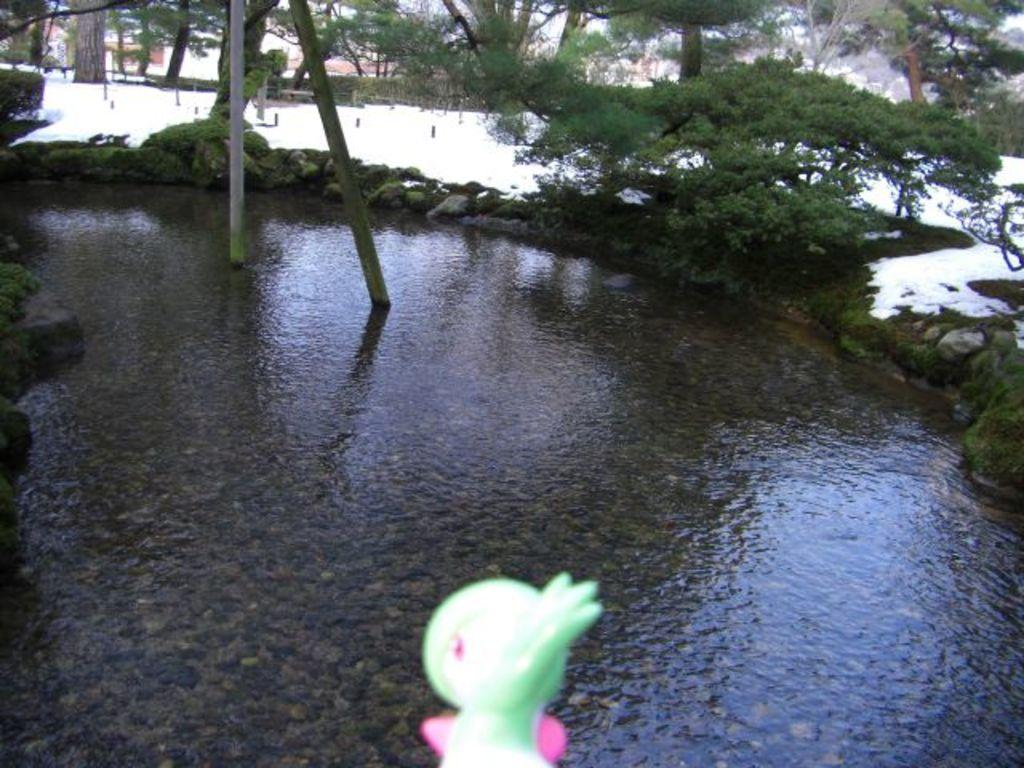What is the primary element present in the image? Water is present in the image. What structures can be seen in the image? There are poles in the image. What type of vegetation is visible in the image? Plants and trees are visible in the image. What weather condition is depicted in the image? Snow is present in the image. How many copies of the peace symbol can be seen in the image? There is no peace symbol present in the image. What type of sticks are used to create the structures in the image? There are no sticks used to create the structures in the image; the poles are not made of sticks. 